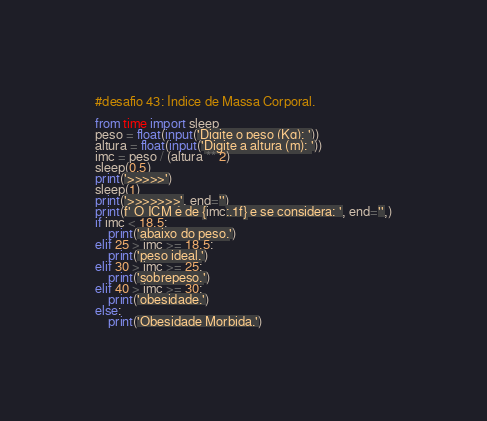Convert code to text. <code><loc_0><loc_0><loc_500><loc_500><_Python_>#desafio 43: Índice de Massa Corporal.

from time import sleep
peso = float(input('Digite o peso (Kg): '))
altura = float(input('Digite a altura (m): '))
imc = peso / (altura ** 2)
sleep(0.5)
print('>>>>>')
sleep(1)
print('>>>>>>>', end='')
print(f' O ICM é de {imc:.1f} e se considera: ', end='',)
if imc < 18.5:
    print('abaixo do peso.')
elif 25 > imc >= 18.5:
    print('peso ideal.')
elif 30 > imc >= 25:
    print('sobrepeso.')
elif 40 > imc >= 30:
    print('obesidade.')
else:
    print('Obesidade Morbida.')
</code> 